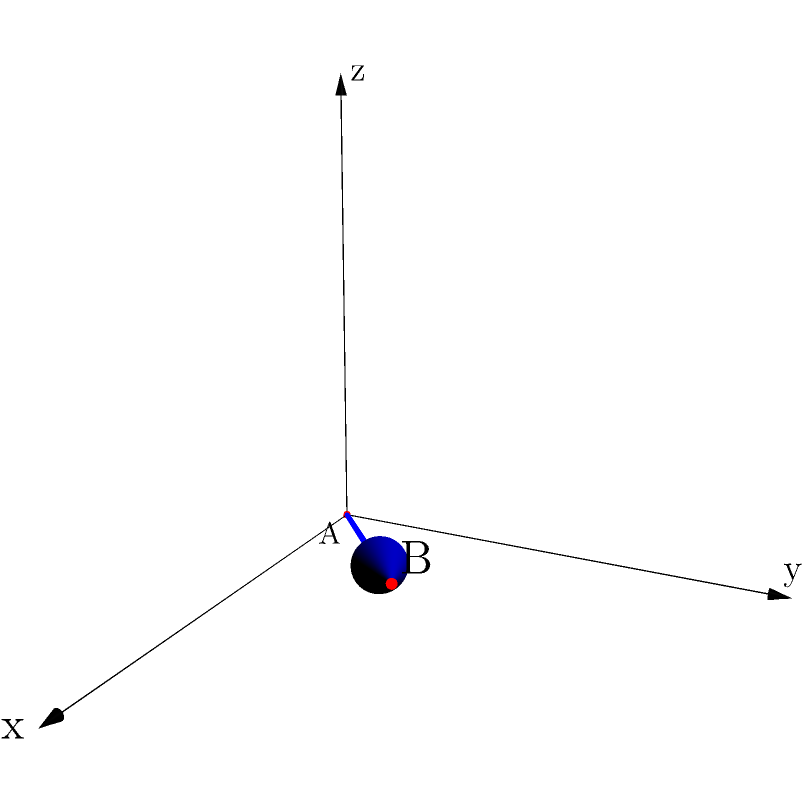Based on the 3D coordinate system shown, a bullet is fired from point A (0,0,0) to point B (3,2,1). Calculate the total distance traveled by the bullet. To find the total distance traveled by the bullet, we need to calculate the length of the vector from point A to point B. This can be done using the following steps:

1. Identify the coordinates:
   Point A: (0,0,0)
   Point B: (3,2,1)

2. Calculate the differences in each coordinate:
   $\Delta x = 3 - 0 = 3$
   $\Delta y = 2 - 0 = 2$
   $\Delta z = 1 - 0 = 1$

3. Use the 3D distance formula:
   Distance = $\sqrt{(\Delta x)^2 + (\Delta y)^2 + (\Delta z)^2}$

4. Substitute the values:
   Distance = $\sqrt{3^2 + 2^2 + 1^2}$

5. Simplify:
   Distance = $\sqrt{9 + 4 + 1}$
   Distance = $\sqrt{14}$

Therefore, the total distance traveled by the bullet is $\sqrt{14}$ units.
Answer: $\sqrt{14}$ units 